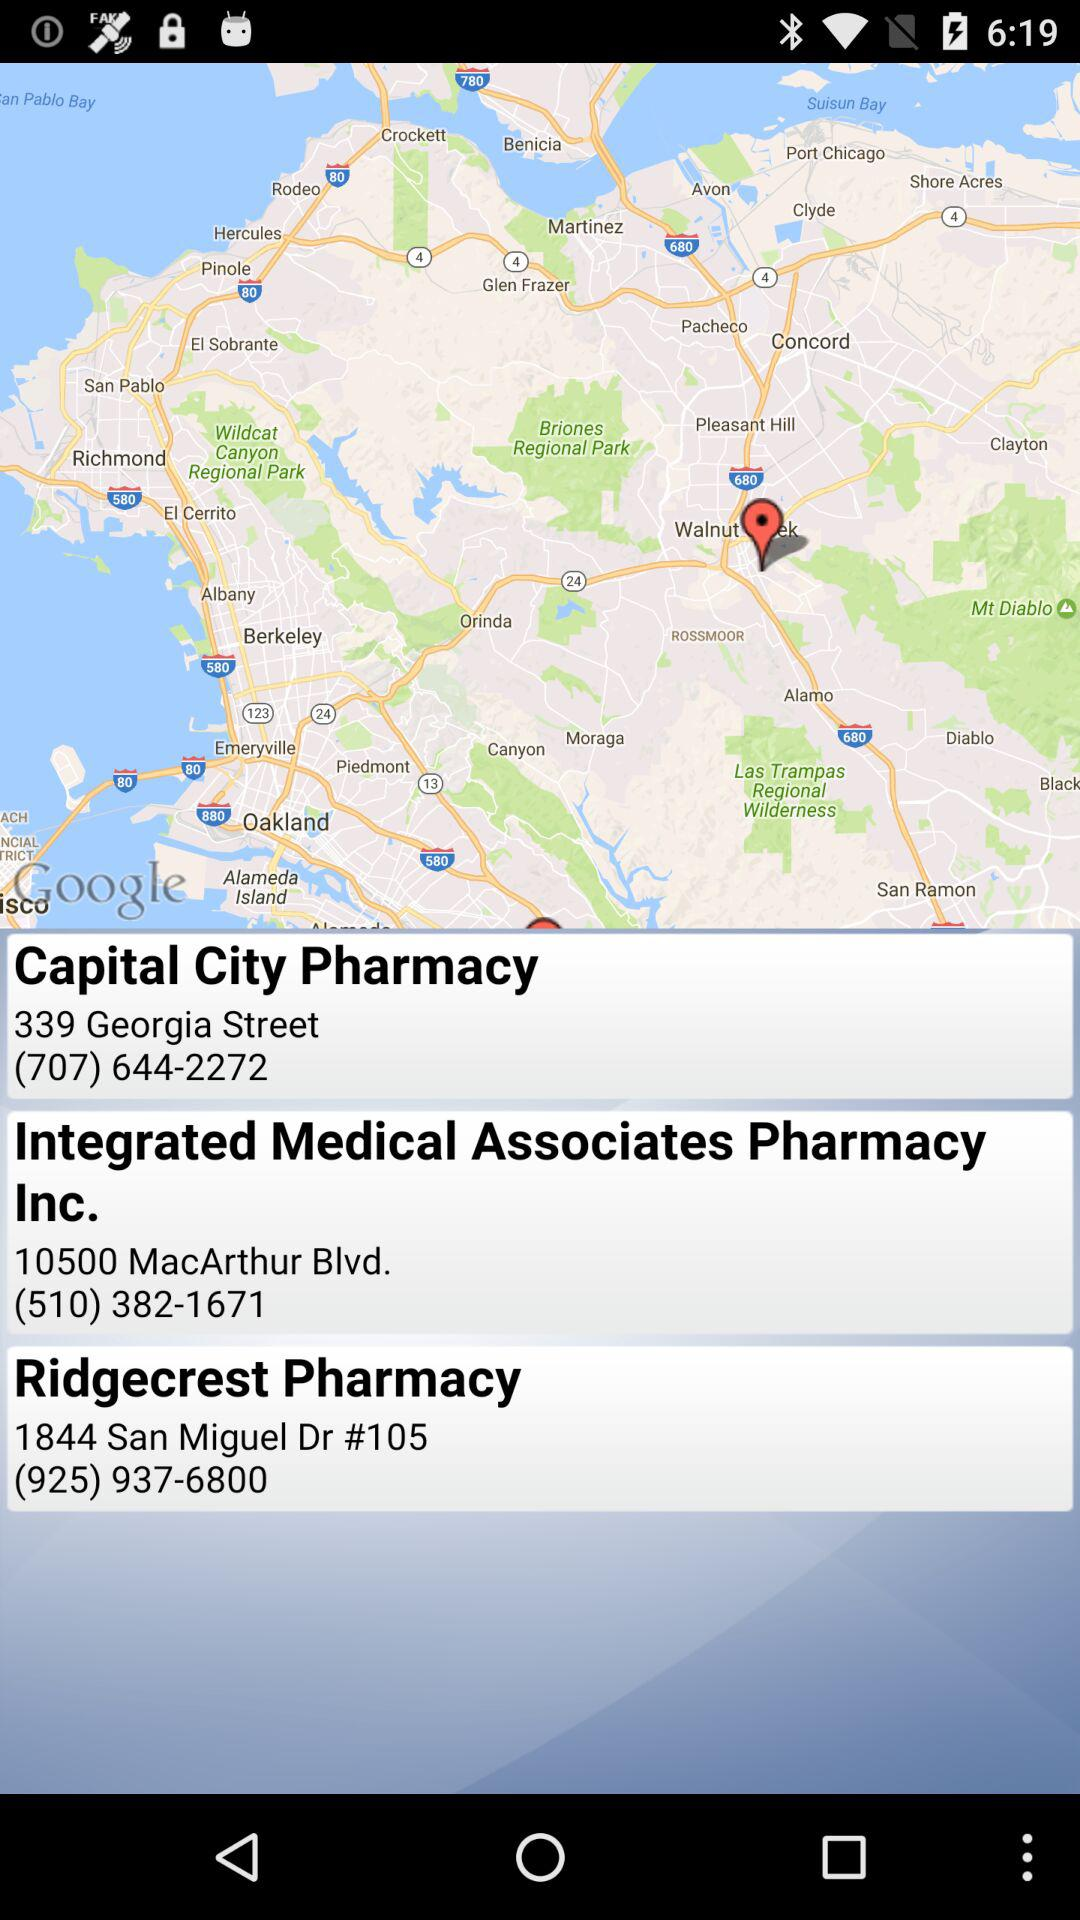How far away is Ridgecrest Pharmacy?
When the provided information is insufficient, respond with <no answer>. <no answer> 